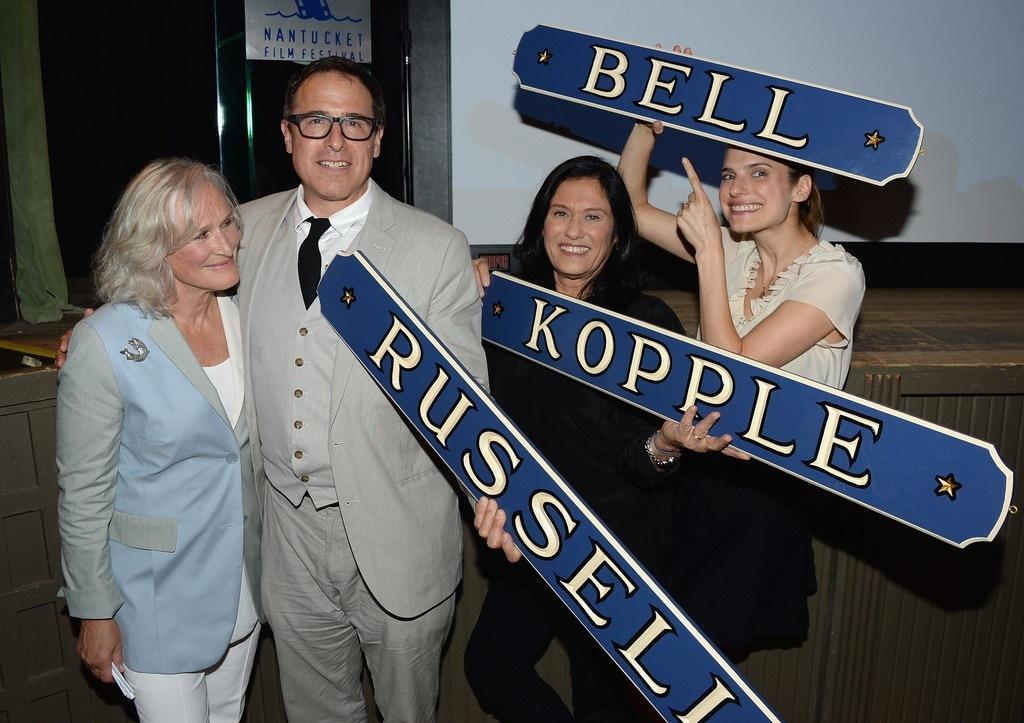Can you describe this image briefly? Here men and women are standing, these are boards, this is wall. 